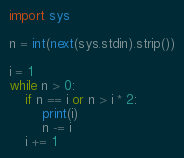<code> <loc_0><loc_0><loc_500><loc_500><_Python_>import sys

n = int(next(sys.stdin).strip())

i = 1
while n > 0:
    if n == i or n > i * 2:
        print(i)
        n -= i
    i += 1
</code> 